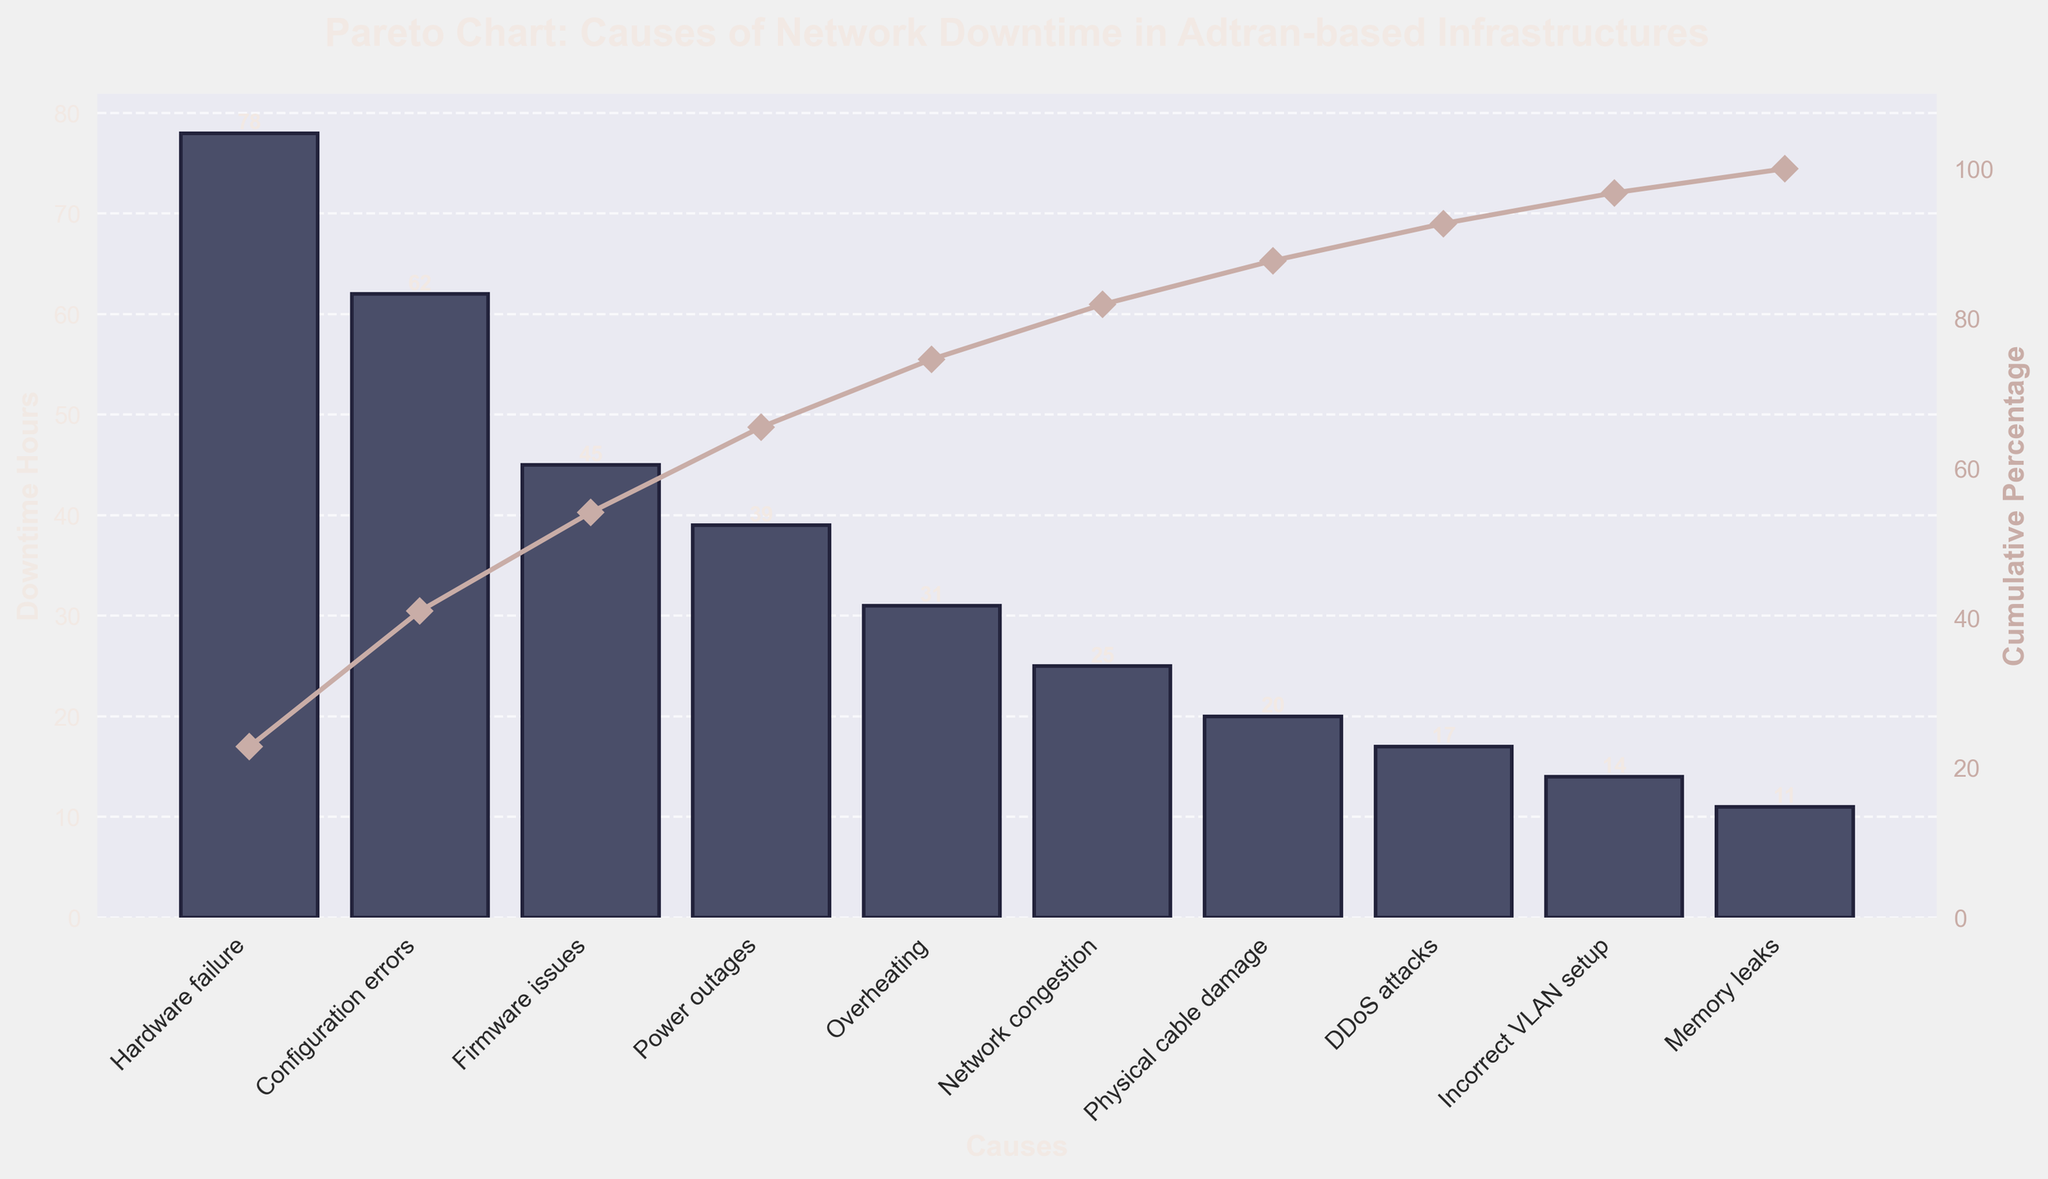What is the title of the chart? The title of the chart is prominently displayed at the top and helps to understand the context of the data being visualized.
Answer: Pareto Chart: Causes of Network Downtime in Adtran-based Infrastructures What cause has the highest downtime hours? The bars represent the downtime hours for each cause, and the tallest bar indicates the cause with the highest downtime.
Answer: Hardware failure Which cause has the lowest downtime hours? The bars represent the downtime hours for each cause, and the shortest bar indicates the cause with the lowest downtime.
Answer: Memory leaks What are the downtime hours for firmware issues? Look for the bar labeled 'Firmware issues' and check the value on the y-axis.
Answer: 45 What percentage of the total downtime is contributed by hardware failure and configuration errors combined? Find the downtime hours for 'Hardware failure' and 'Configuration errors' and sum them. Divide by the total downtime hours and multiply by 100.
Answer: 40.7% List the top three causes of network downtime by impact. Identify the three tallest bars and note the corresponding causes. A glance at the Pareto chart reveals them easily.
Answer: Hardware failure, Configuration errors, Firmware issues How does the cumulative percentage for 'Overheating' compare to 'DDoS attacks'? Find the cumulative percentage values for 'Overheating' and 'DDoS attacks' on the secondary y-axis (right side) and compare them.
Answer: Higher for Overheating Which cause contributes more to network downtime: 'Network congestion' or 'Power outages'? Compare the heights of the bars labeled 'Network congestion' and 'Power outages'.
Answer: Power outages How many causes account for approximately 80% of the network downtime? Locate where the cumulative percentage curve crosses the 80% mark on the y-axis and count the number of causes up to that point.
Answer: Five causes What is the cumulative percentage after including the downtime hours from 'Physical cable damage'? Find the cumulative percentage value corresponding to 'Physical cable damage' on the secondary y-axis.
Answer: 93.6% 